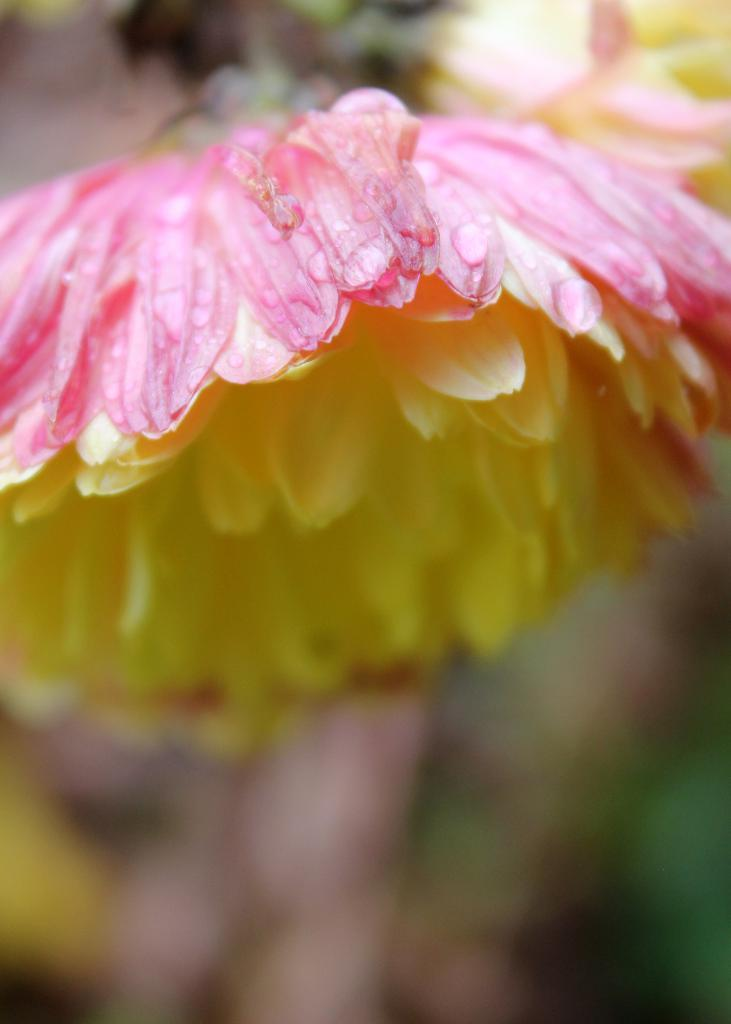What is the main subject of the image? There is a flower in the center of the image. Can you describe the colors of the flower? The flower has pink and yellow colors. What advice did the mother give to the grandfather during their discussion in the image? There is no mother, grandfather, or discussion present in the image; it only features a flower with pink and yellow colors. 